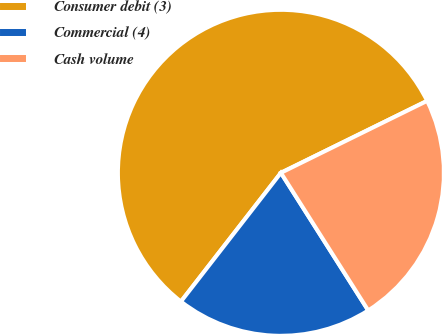<chart> <loc_0><loc_0><loc_500><loc_500><pie_chart><fcel>Consumer debit (3)<fcel>Commercial (4)<fcel>Cash volume<nl><fcel>57.22%<fcel>19.51%<fcel>23.28%<nl></chart> 